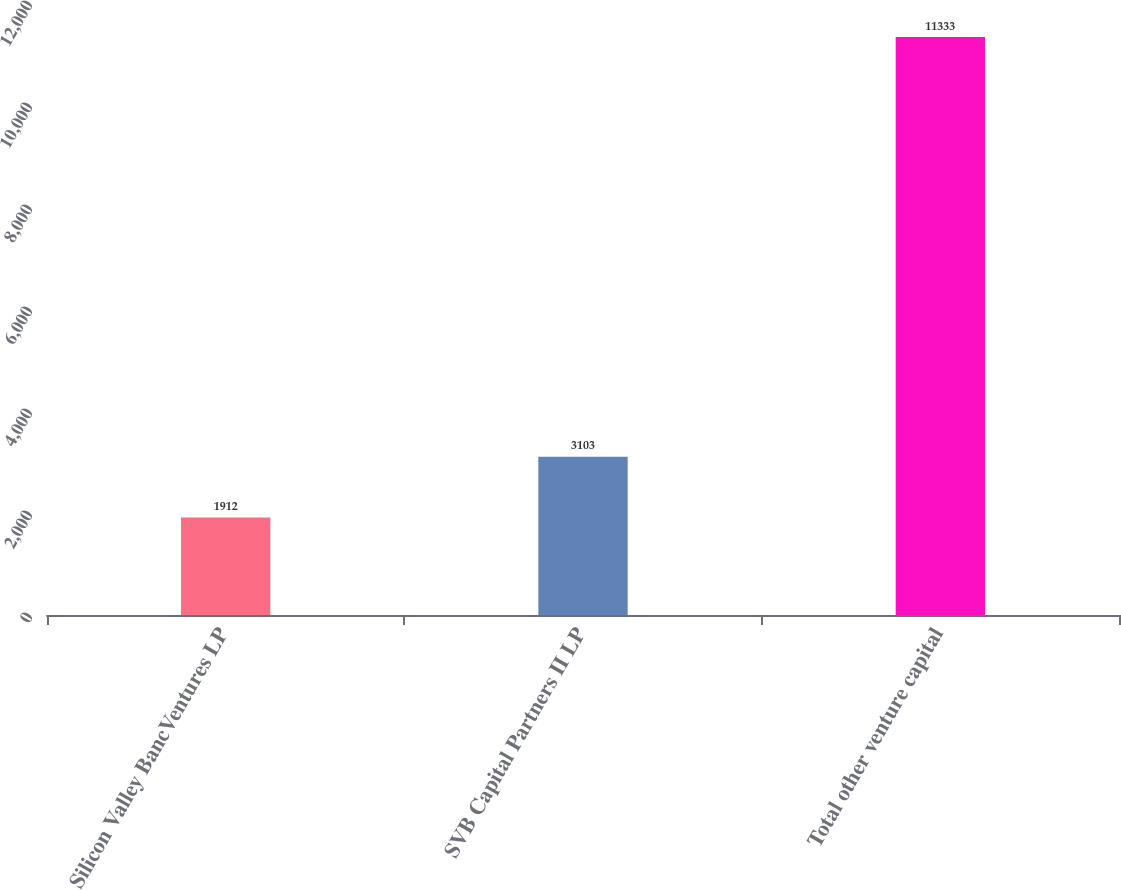Convert chart. <chart><loc_0><loc_0><loc_500><loc_500><bar_chart><fcel>Silicon Valley BancVentures LP<fcel>SVB Capital Partners II LP<fcel>Total other venture capital<nl><fcel>1912<fcel>3103<fcel>11333<nl></chart> 